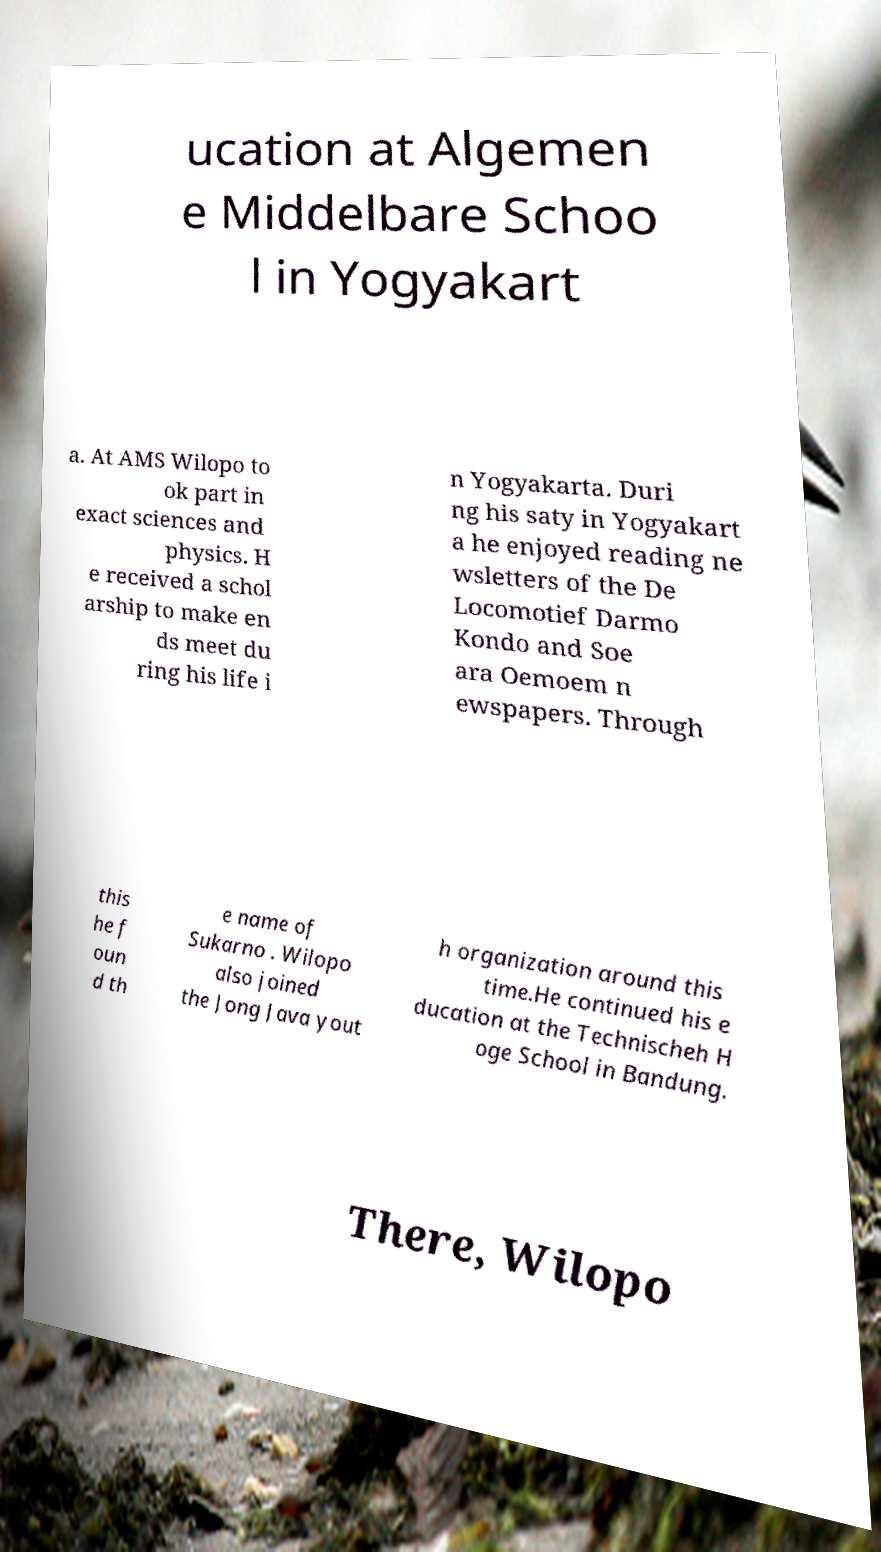I need the written content from this picture converted into text. Can you do that? ucation at Algemen e Middelbare Schoo l in Yogyakart a. At AMS Wilopo to ok part in exact sciences and physics. H e received a schol arship to make en ds meet du ring his life i n Yogyakarta. Duri ng his saty in Yogyakart a he enjoyed reading ne wsletters of the De Locomotief Darmo Kondo and Soe ara Oemoem n ewspapers. Through this he f oun d th e name of Sukarno . Wilopo also joined the Jong Java yout h organization around this time.He continued his e ducation at the Technischeh H oge School in Bandung. There, Wilopo 